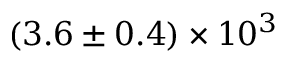Convert formula to latex. <formula><loc_0><loc_0><loc_500><loc_500>( 3 . 6 \pm 0 . 4 ) \times 1 0 ^ { 3 }</formula> 